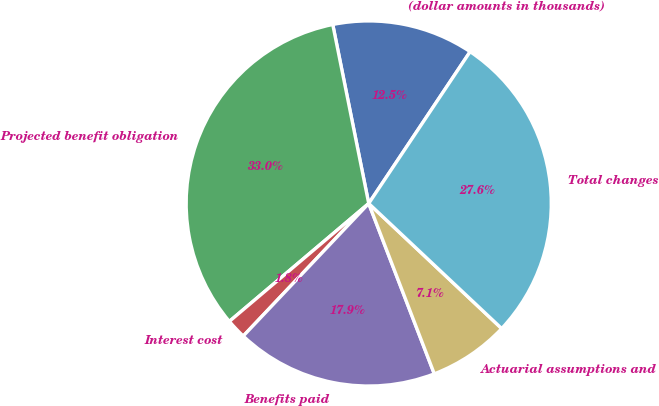<chart> <loc_0><loc_0><loc_500><loc_500><pie_chart><fcel>(dollar amounts in thousands)<fcel>Projected benefit obligation<fcel>Interest cost<fcel>Benefits paid<fcel>Actuarial assumptions and<fcel>Total changes<nl><fcel>12.53%<fcel>33.02%<fcel>1.76%<fcel>17.91%<fcel>7.14%<fcel>27.64%<nl></chart> 